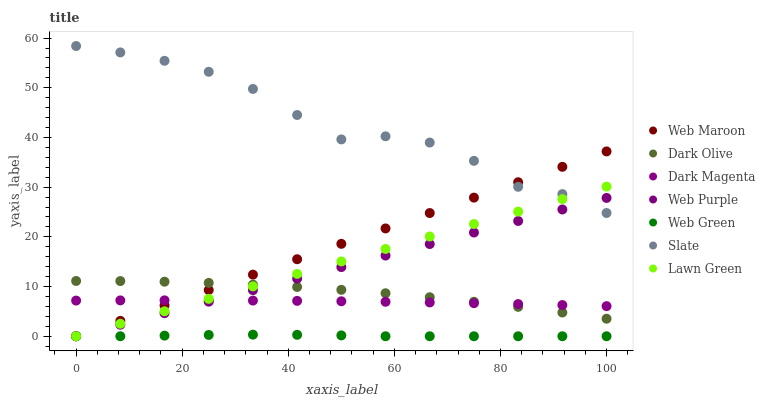Does Web Green have the minimum area under the curve?
Answer yes or no. Yes. Does Slate have the maximum area under the curve?
Answer yes or no. Yes. Does Dark Magenta have the minimum area under the curve?
Answer yes or no. No. Does Dark Magenta have the maximum area under the curve?
Answer yes or no. No. Is Web Purple the smoothest?
Answer yes or no. Yes. Is Slate the roughest?
Answer yes or no. Yes. Is Dark Magenta the smoothest?
Answer yes or no. No. Is Dark Magenta the roughest?
Answer yes or no. No. Does Lawn Green have the lowest value?
Answer yes or no. Yes. Does Dark Magenta have the lowest value?
Answer yes or no. No. Does Slate have the highest value?
Answer yes or no. Yes. Does Dark Magenta have the highest value?
Answer yes or no. No. Is Web Green less than Slate?
Answer yes or no. Yes. Is Dark Magenta greater than Web Green?
Answer yes or no. Yes. Does Lawn Green intersect Dark Magenta?
Answer yes or no. Yes. Is Lawn Green less than Dark Magenta?
Answer yes or no. No. Is Lawn Green greater than Dark Magenta?
Answer yes or no. No. Does Web Green intersect Slate?
Answer yes or no. No. 